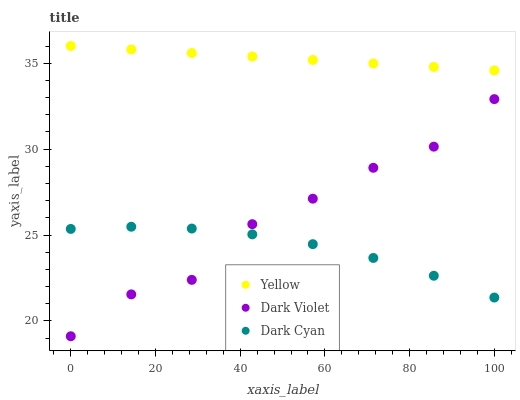Does Dark Cyan have the minimum area under the curve?
Answer yes or no. Yes. Does Yellow have the maximum area under the curve?
Answer yes or no. Yes. Does Dark Violet have the minimum area under the curve?
Answer yes or no. No. Does Dark Violet have the maximum area under the curve?
Answer yes or no. No. Is Yellow the smoothest?
Answer yes or no. Yes. Is Dark Violet the roughest?
Answer yes or no. Yes. Is Dark Violet the smoothest?
Answer yes or no. No. Is Yellow the roughest?
Answer yes or no. No. Does Dark Violet have the lowest value?
Answer yes or no. Yes. Does Yellow have the lowest value?
Answer yes or no. No. Does Yellow have the highest value?
Answer yes or no. Yes. Does Dark Violet have the highest value?
Answer yes or no. No. Is Dark Cyan less than Yellow?
Answer yes or no. Yes. Is Yellow greater than Dark Cyan?
Answer yes or no. Yes. Does Dark Violet intersect Dark Cyan?
Answer yes or no. Yes. Is Dark Violet less than Dark Cyan?
Answer yes or no. No. Is Dark Violet greater than Dark Cyan?
Answer yes or no. No. Does Dark Cyan intersect Yellow?
Answer yes or no. No. 